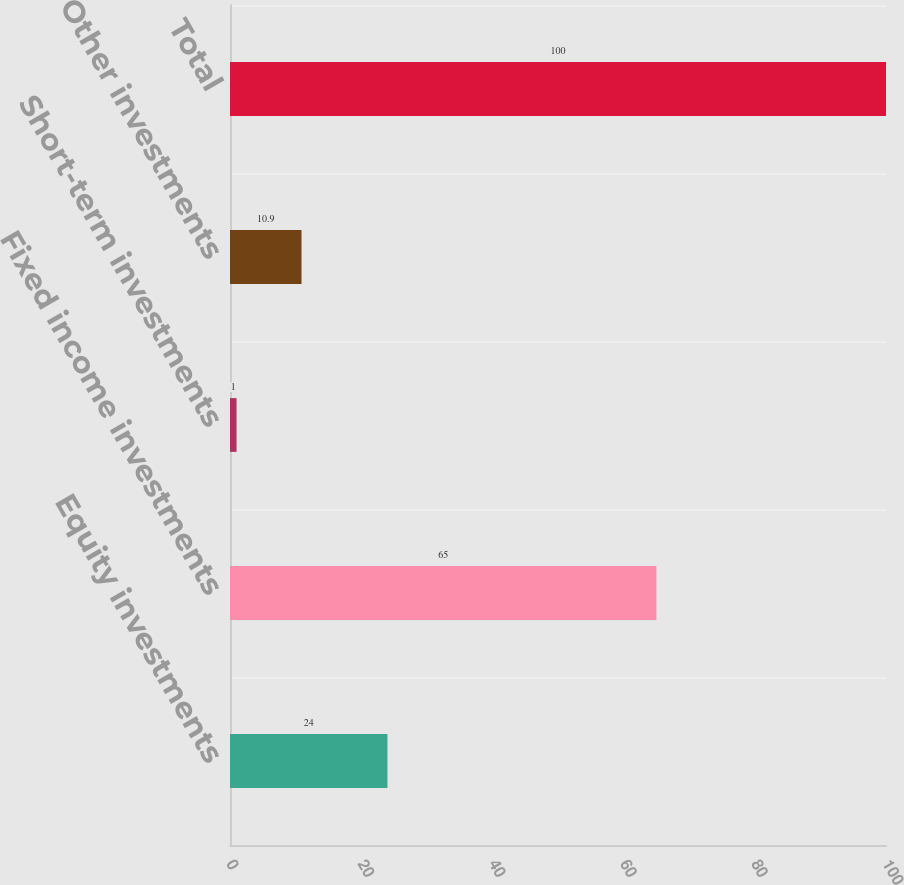Convert chart to OTSL. <chart><loc_0><loc_0><loc_500><loc_500><bar_chart><fcel>Equity investments<fcel>Fixed income investments<fcel>Short-term investments<fcel>Other investments<fcel>Total<nl><fcel>24<fcel>65<fcel>1<fcel>10.9<fcel>100<nl></chart> 